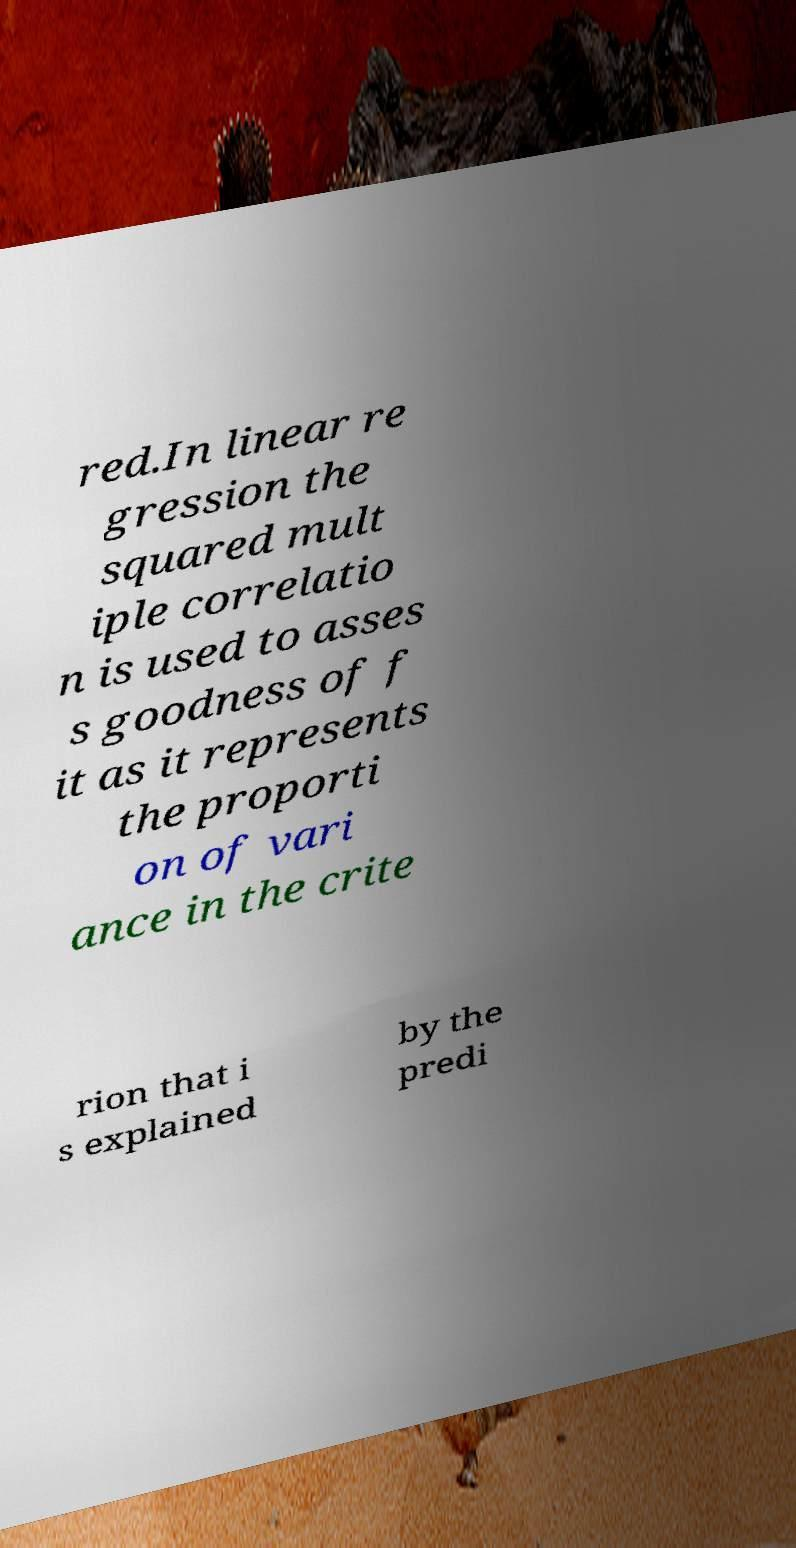What messages or text are displayed in this image? I need them in a readable, typed format. red.In linear re gression the squared mult iple correlatio n is used to asses s goodness of f it as it represents the proporti on of vari ance in the crite rion that i s explained by the predi 